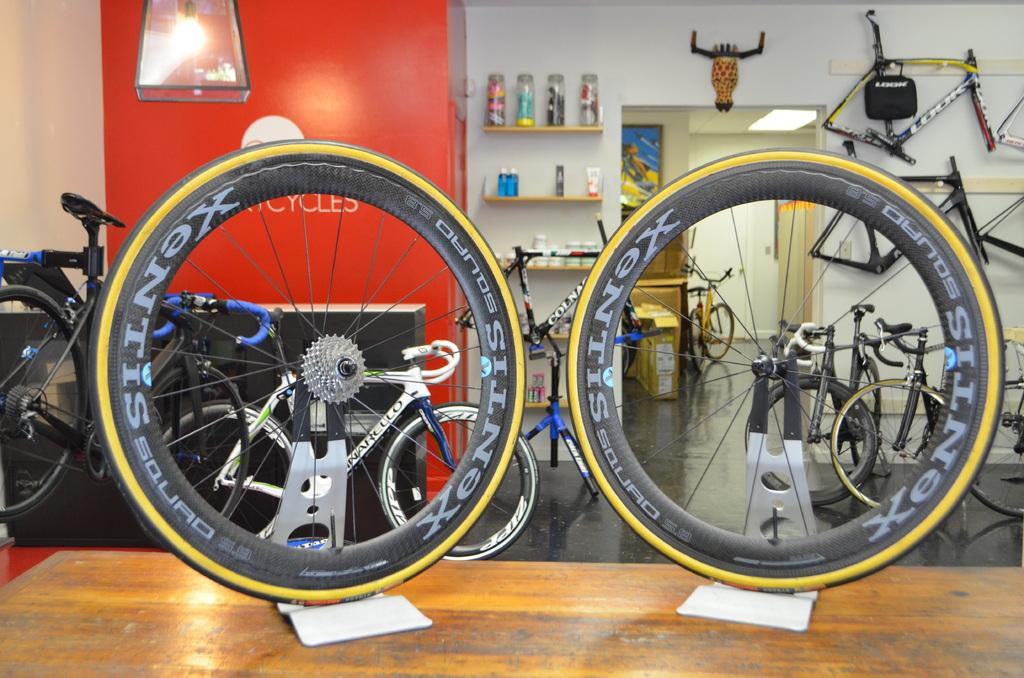What is the main object in the middle of the image? There is a table in the middle of the image. What is placed on the table? Tires are present on the table. What can be seen in the background of the image? There are many bicycles, tires, cycle parts, bottles, shelves, a light, a door, and a wall visible in the background of the image. Where is the crate of amusement park tickets located in the image? There is no crate of amusement park tickets present in the image. What type of flower can be seen growing near the door in the image? There are no flowers visible in the image. 